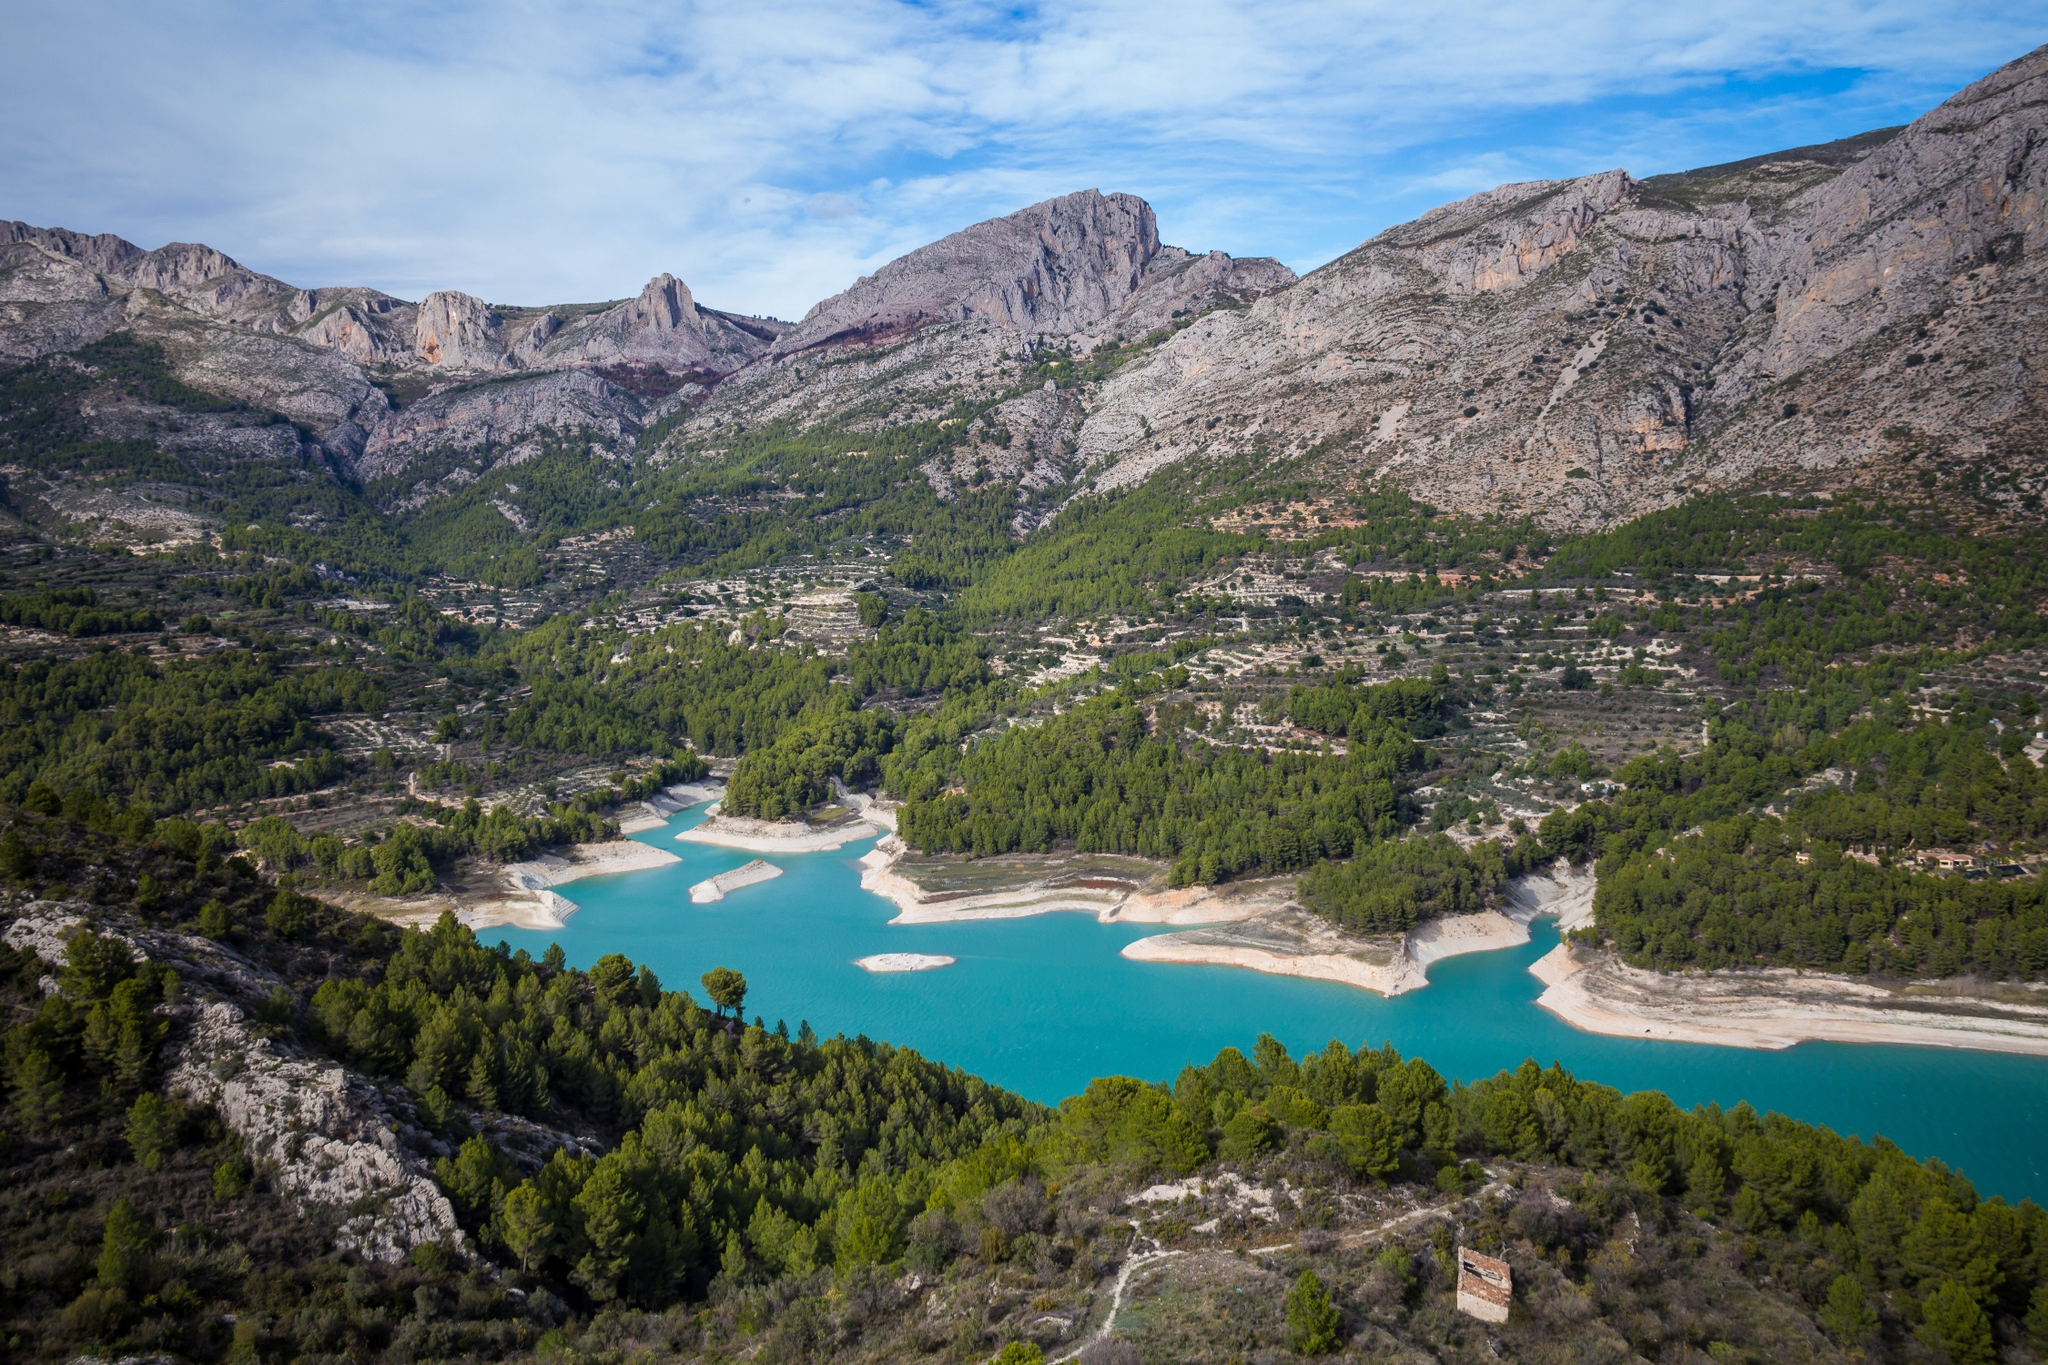Can you elaborate on the elements of the picture provided? The image captures an aerial view of the Guadalest Reservoir, a renowned landmark located in Alicante, Spain. The reservoir, with its bright blue color, stands out against the surrounding landscape. It's nestled amidst an expanse of greenery, with trees and shrubs encircling it, providing a vibrant contrast to the water. In the distance, the gray and brown hues of the mountains create a stunning backdrop. Above, the sky is a light blue, dotted with white clouds. The perspective of the image is from above, offering a comprehensive view of the reservoir and the breathtaking scenery that surrounds it. The image code "sa_16178" could be a reference to the specific viewpoint or location from where the photo was taken. 